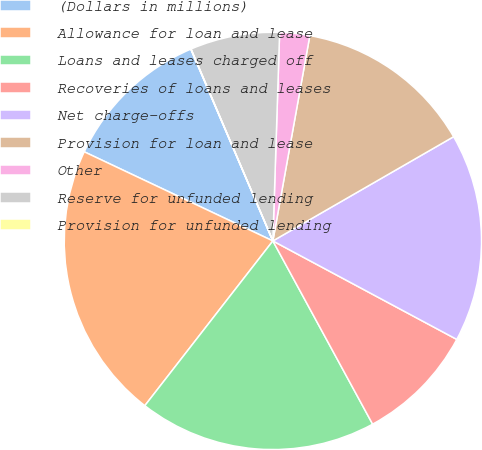Convert chart. <chart><loc_0><loc_0><loc_500><loc_500><pie_chart><fcel>(Dollars in millions)<fcel>Allowance for loan and lease<fcel>Loans and leases charged off<fcel>Recoveries of loans and leases<fcel>Net charge-offs<fcel>Provision for loan and lease<fcel>Other<fcel>Reserve for unfunded lending<fcel>Provision for unfunded lending<nl><fcel>11.54%<fcel>21.51%<fcel>18.45%<fcel>9.24%<fcel>16.15%<fcel>13.84%<fcel>2.32%<fcel>6.93%<fcel>0.02%<nl></chart> 